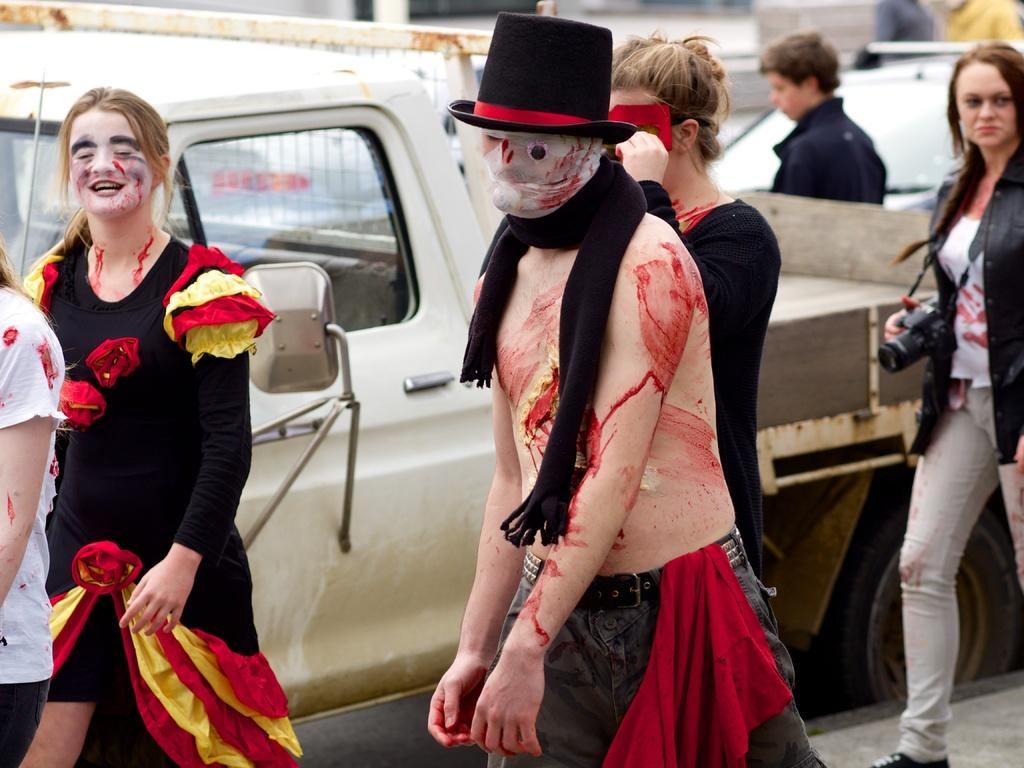How many people are in the image? There are two people in the image, a man and a woman. What are the man and woman wearing? Both the man and woman are wearing costumes. Where is the woman holding a camera located in the image? The woman holding a camera is at the right side of the image. What vehicles can be seen in the background of the image? There is a truck and a car in the background of the image. What type of mist can be seen surrounding the people in the image? There is no mist present in the image; it is a clear scene with the man and woman wearing costumes. Can you describe the flight path of the birds in the image? There are no birds present in the image, so it is not possible to describe their flight path. 